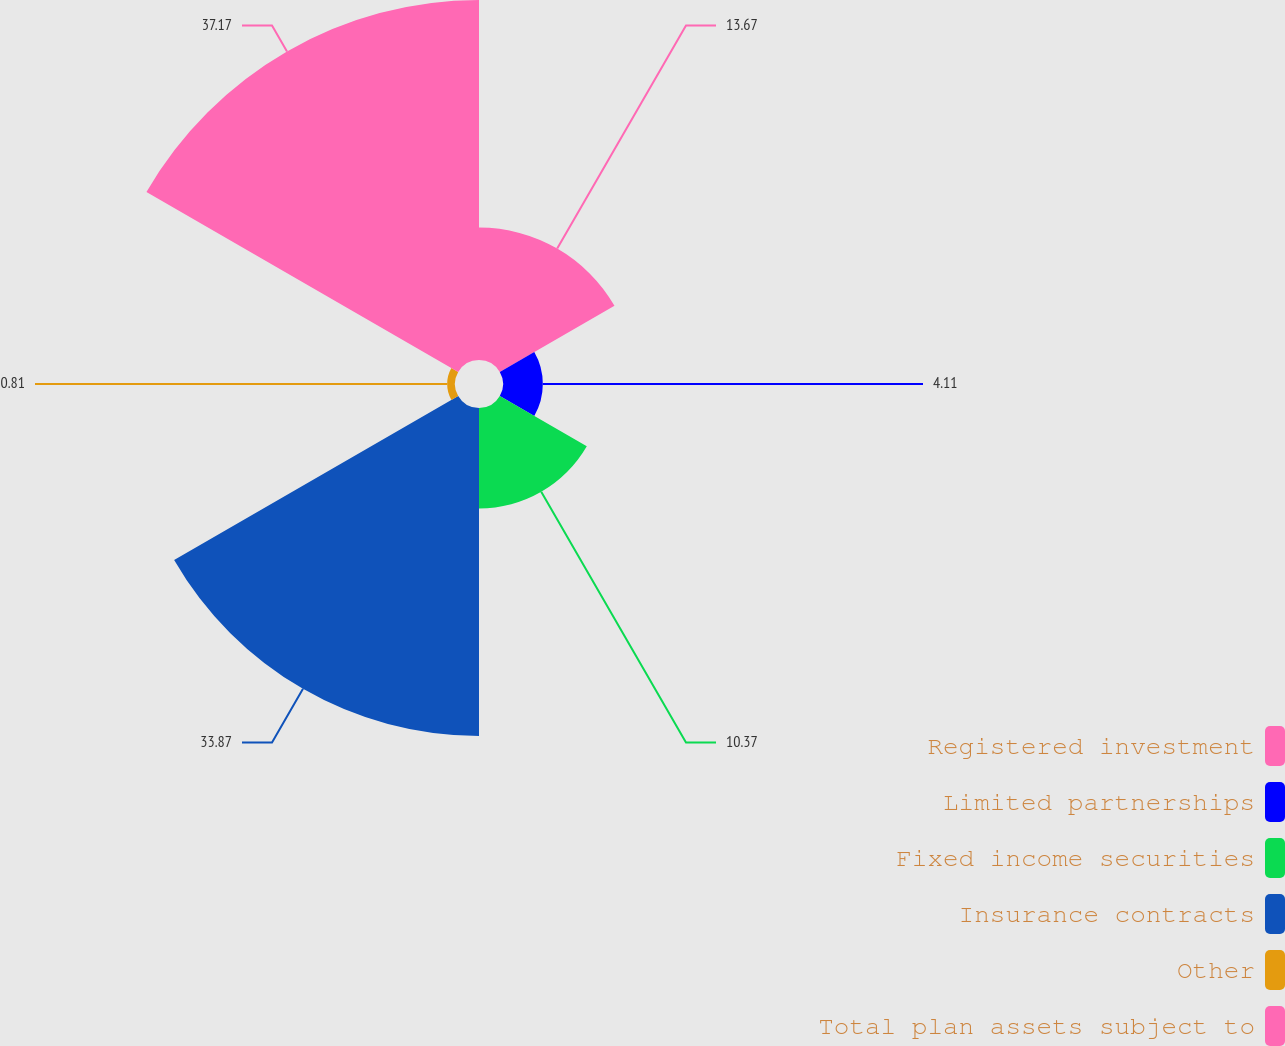<chart> <loc_0><loc_0><loc_500><loc_500><pie_chart><fcel>Registered investment<fcel>Limited partnerships<fcel>Fixed income securities<fcel>Insurance contracts<fcel>Other<fcel>Total plan assets subject to<nl><fcel>13.67%<fcel>4.11%<fcel>10.37%<fcel>33.86%<fcel>0.81%<fcel>37.16%<nl></chart> 